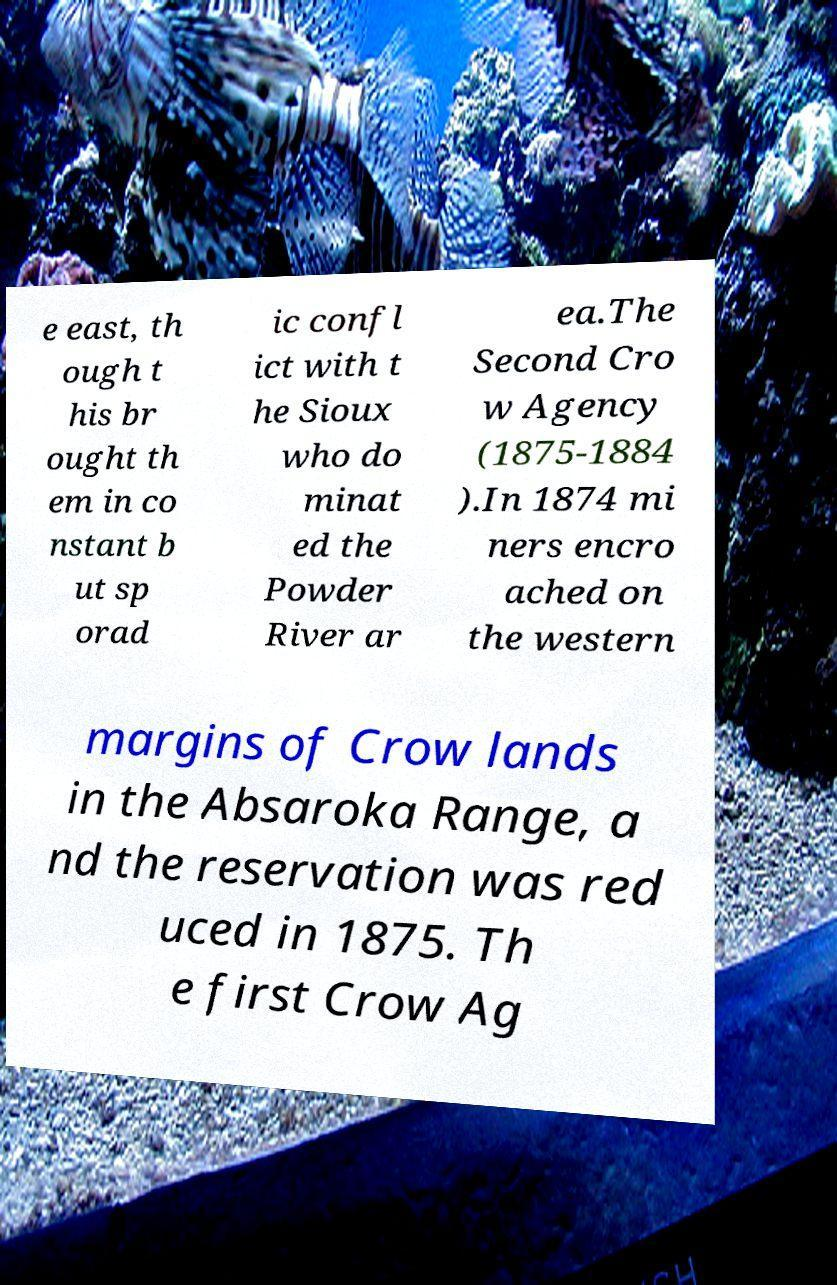Could you assist in decoding the text presented in this image and type it out clearly? e east, th ough t his br ought th em in co nstant b ut sp orad ic confl ict with t he Sioux who do minat ed the Powder River ar ea.The Second Cro w Agency (1875-1884 ).In 1874 mi ners encro ached on the western margins of Crow lands in the Absaroka Range, a nd the reservation was red uced in 1875. Th e first Crow Ag 